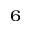<formula> <loc_0><loc_0><loc_500><loc_500>_ { 6 }</formula> 